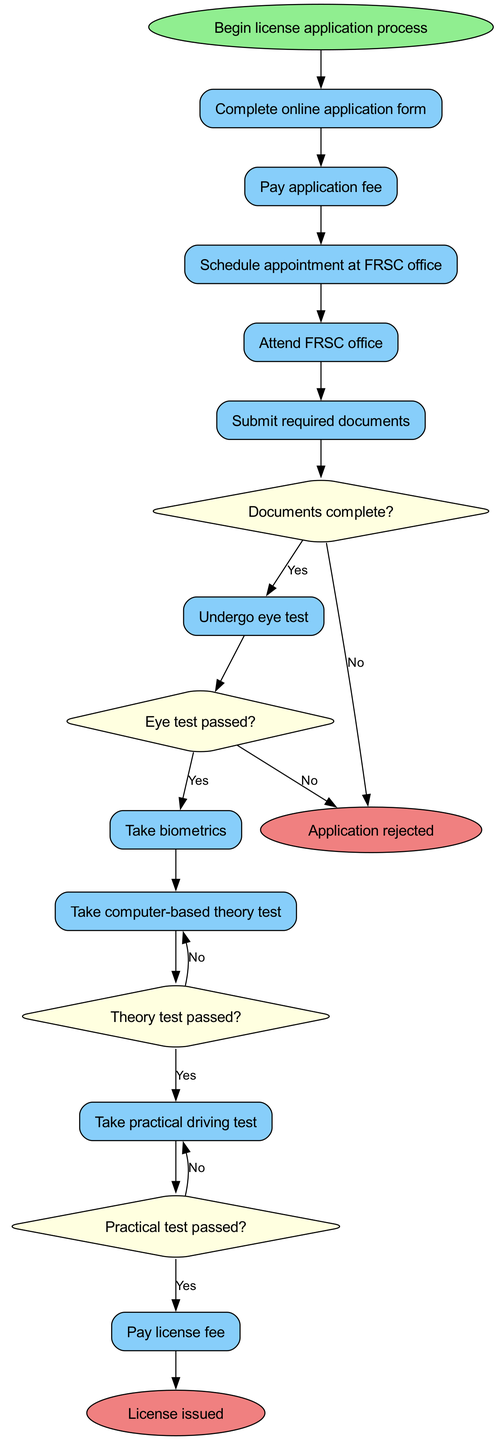What is the starting point of the license application process? The starting point is denoted in the diagram as "Begin license application process," which is clearly marked as the initial node.
Answer: Begin license application process How many decisions are present in the diagram? By reviewing the nodes in the decisions section, we find a total of four decision nodes listed in the diagram: "Documents complete?", "Eye test passed?", "Theory test passed?", and "Practical test passed?"
Answer: 4 What is the last activity before issuing a license? The last activity in the sequence that connects to the issuing of the license is "Pay license fee," as indicated by the arrow leading to the final outcome of the process.
Answer: Pay license fee What happens if the eye test is not passed? If the eye test is not passed, the diagram indicates that the flow leads to the end node "Application rejected," showing that an unsuccessful eye test results in application denial.
Answer: Application rejected Which activity follows the submission of required documents? After the activity "Submit required documents," the next activity listed in the sequence is "Undergo eye test," as depicted by the connecting edge.
Answer: Undergo eye test What is the outcome if the practical test is failed? Upon failing the practical test, the next step in the diagram indicates a return to the previous activity, which means the individual would need to "Retake test" before proceeding, reflecting the requirement to attempt it again.
Answer: Retake test What are the two possible end states of the application process? The application process can conclude in two ways: either "License issued" or "Application rejected," as detailed in the final node section of the diagram.
Answer: License issued, Application rejected Which activity directly follows the payment of the application fee? The activity that follows "Pay application fee" is "Schedule appointment at FRSC office," as indicated by the sequence in the diagram connecting these two activities.
Answer: Schedule appointment at FRSC office 